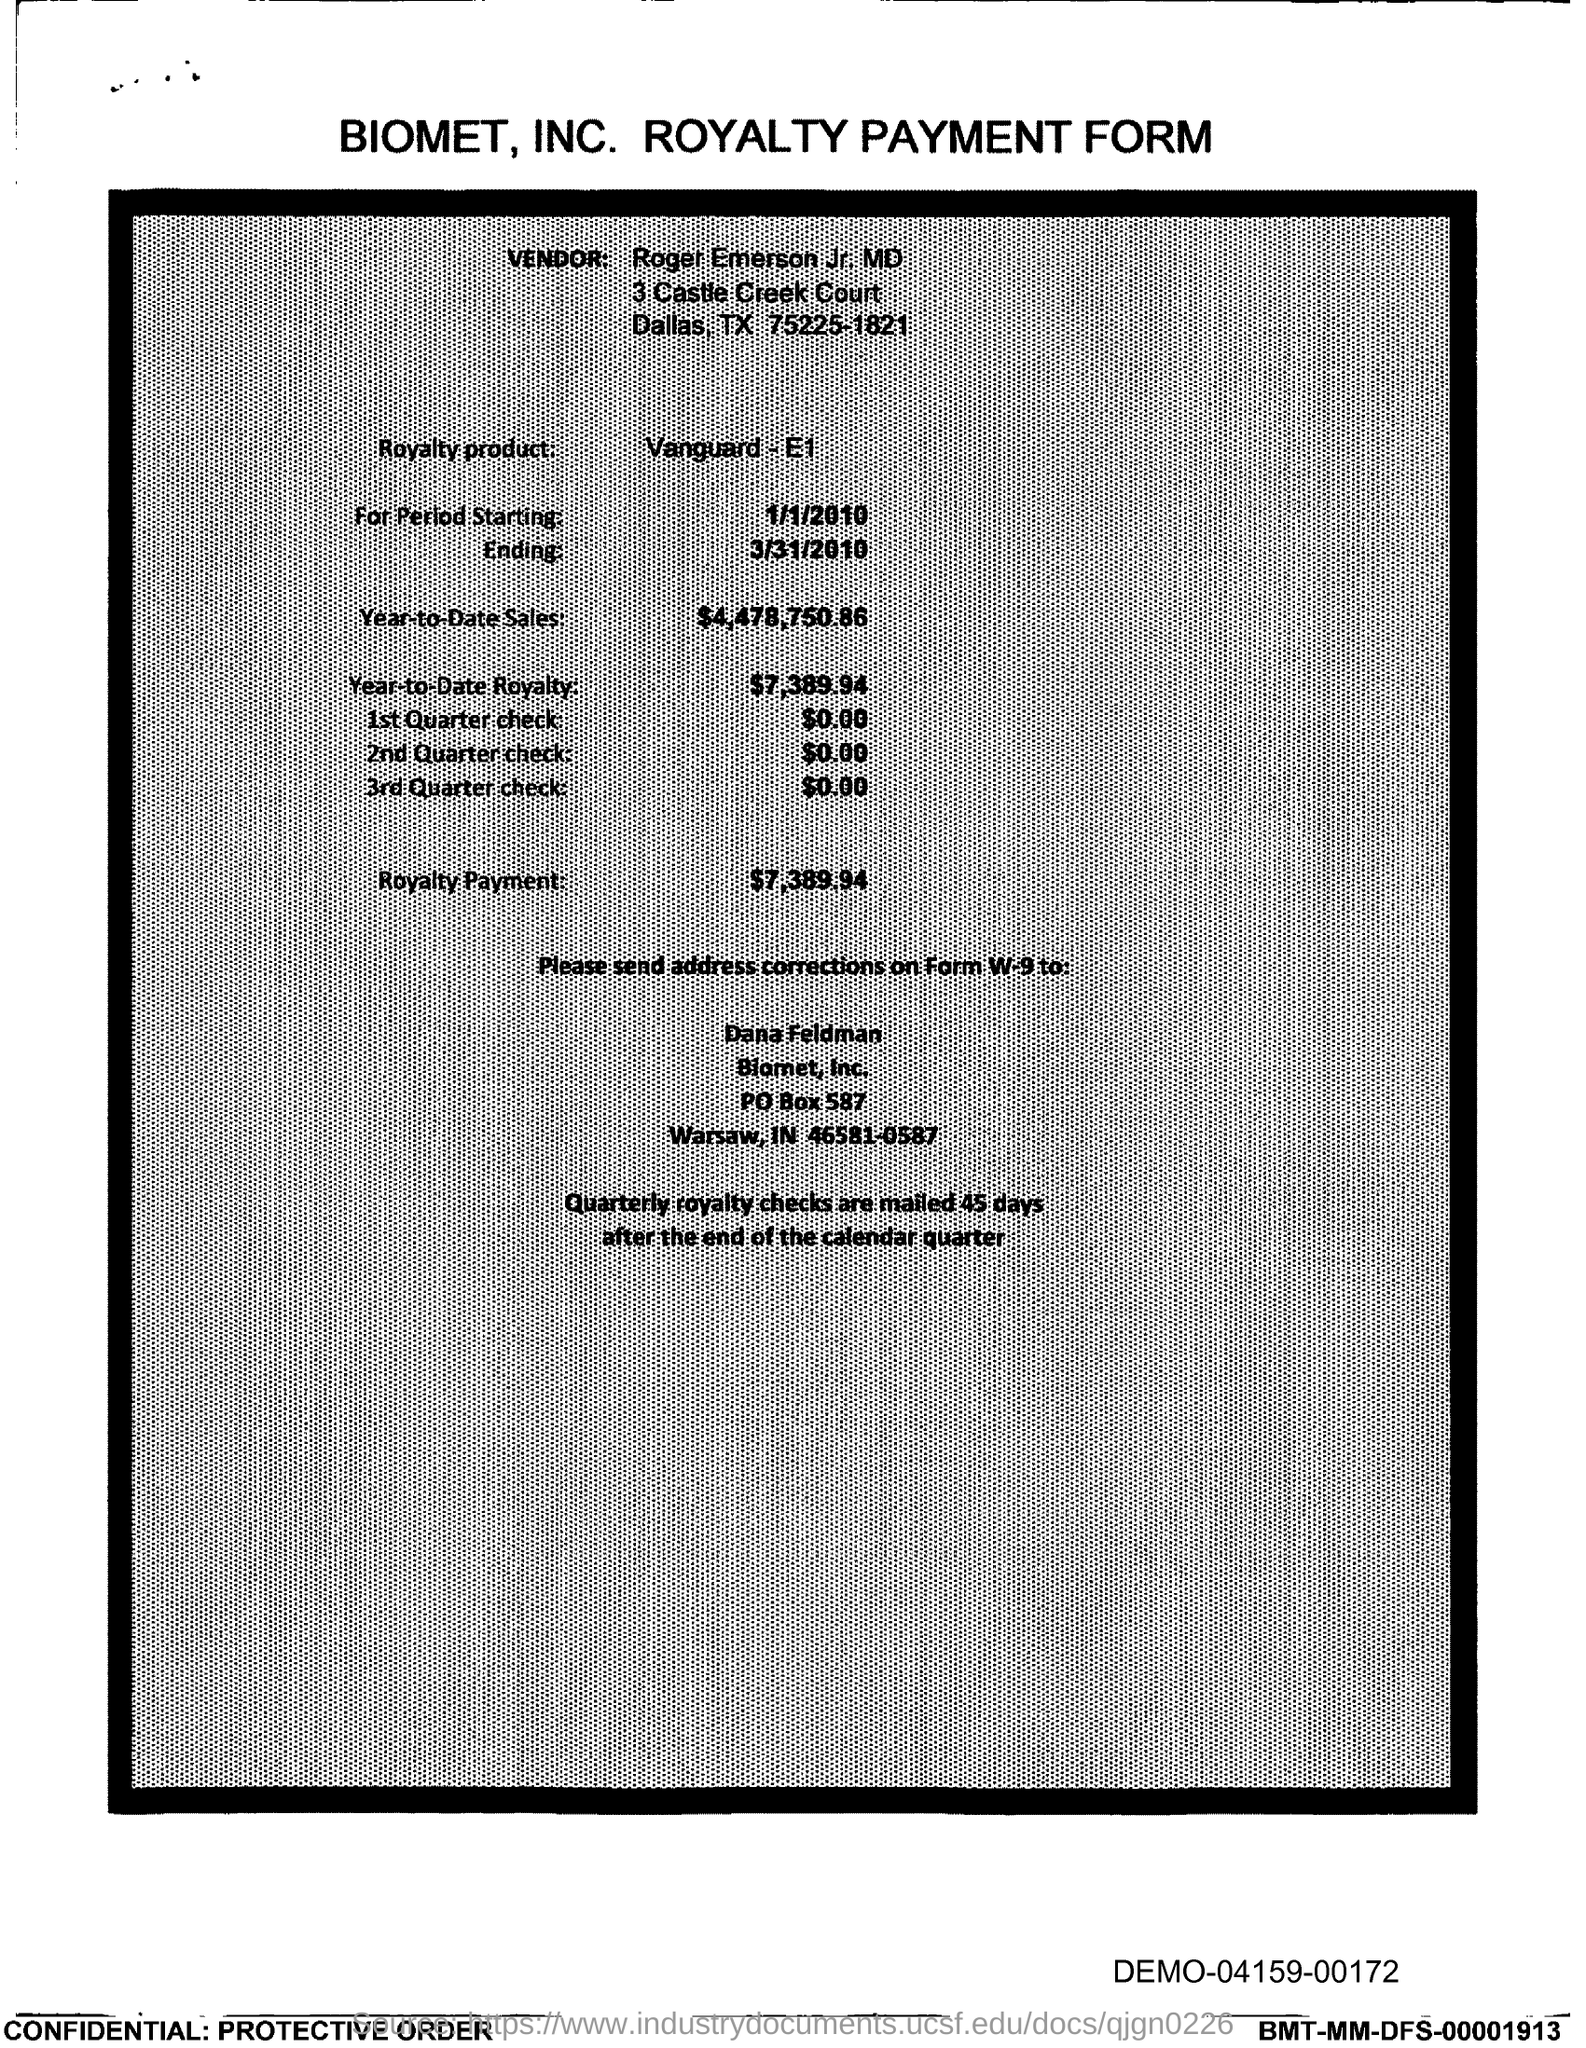Highlight a few significant elements in this photo. The royalty payment specified is $7,389.94. The year-to-date sales as of now are $4,478,750.86. The Royalty product mentioned is Vanguard-E1. The correction of the address on Form W-9 should be directed to Dana Feldman. 